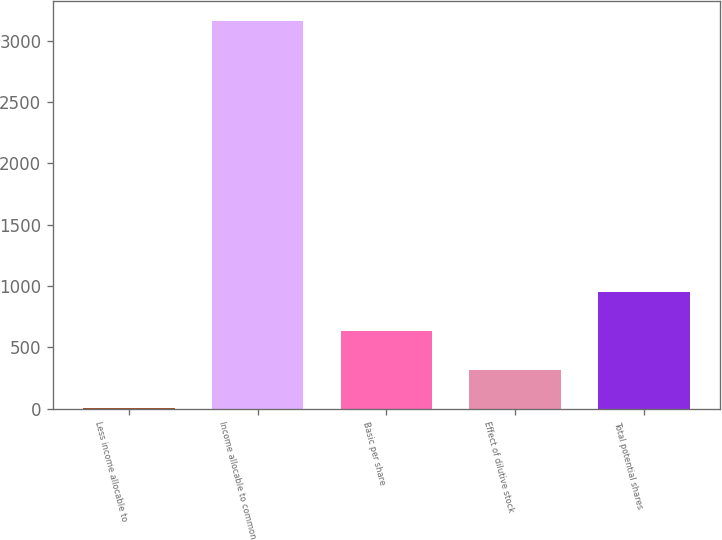<chart> <loc_0><loc_0><loc_500><loc_500><bar_chart><fcel>Less income allocable to<fcel>Income allocable to common<fcel>Basic per share<fcel>Effect of dilutive stock<fcel>Total potential shares<nl><fcel>1<fcel>3160.7<fcel>632.94<fcel>316.97<fcel>948.91<nl></chart> 